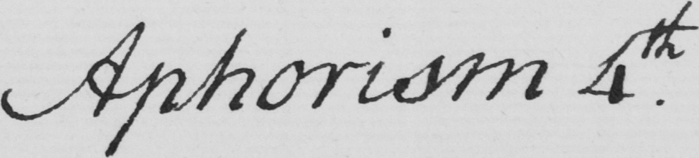Please transcribe the handwritten text in this image. Aphorism 4th 